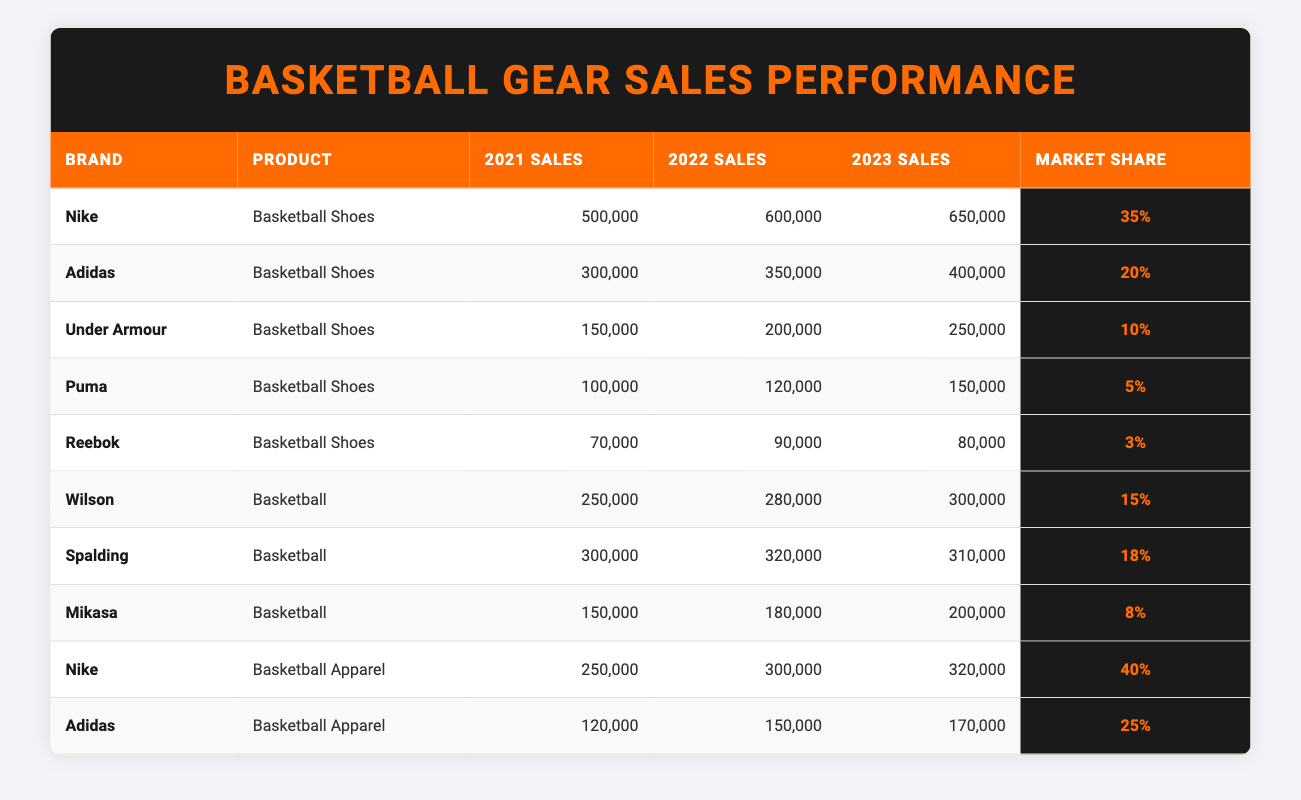What brand had the highest sales in 2023? Looking at the 2023 sales column, Nike had the highest sales of 650,000 for Basketball Shoes.
Answer: Nike Which brand had the lowest market share? The brand with the lowest market share listed is Reebok, with only 3%.
Answer: Reebok What was the total sales for Adidas Basketball Shoes over the three years? To find the total sales for Adidas Basketball Shoes, you sum 300,000 (2021) + 350,000 (2022) + 400,000 (2023) = 1,050,000.
Answer: 1,050,000 Which brand of Basketball Apparel had a larger market share, Nike or Adidas? Nike had a market share of 40% while Adidas had 25%, indicating that Nike had the larger market share.
Answer: Nike What was the percentage increase in sales for Under Armour Basketball Shoes from 2021 to 2023? The sales in 2021 were 150,000 and in 2023 it was 250,000. The increase is 250,000 - 150,000 = 100,000. To find the percentage increase: (100,000 / 150,000) * 100 = 66.67%.
Answer: 66.67% Which product had the highest combined sales in 2023? In 2023, Basketball Shoes (Nike, Adidas, Under Armour, Puma, Reebok) had total sales of 650,000 + 400,000 + 250,000 + 150,000 + 80,000 = 1,530,000, while Basketball (Wilson, Spalding, Mikasa) had 300,000 + 310,000 + 200,000 = 810,000. Basketball Shoes had the highest combined sales.
Answer: Basketball Shoes What is the average sales for Spalding Basketballs over the three years? The sales figures for Spalding are 300,000 (2021), 320,000 (2022), and 310,000 (2023). The total sales are 300,000 + 320,000 + 310,000 = 930,000, and the average is 930,000 / 3 = 310,000.
Answer: 310,000 Did Mikasa Basketball sales increase every year? Checking Mikasa's sales: 150,000 in 2021, 180,000 in 2022 (increase), but only 200,000 in 2023 (also an increase). Thus, Mikasa's sales increased every year.
Answer: Yes Which two brands had a combined market share of more than 50% in Basketball Shoes? Adding the market shares of Nike (35%) and Adidas (20%) gives 55%, which is more than 50%. Hence, Nike and Adidas together have a combined market share greater than 50%.
Answer: Nike and Adidas What is the sales difference between Nike and Adidas Basketball Apparel in 2023? Nike sold 320,000 and Adidas sold 170,000 in 2023. The difference is 320,000 - 170,000 = 150,000.
Answer: 150,000 